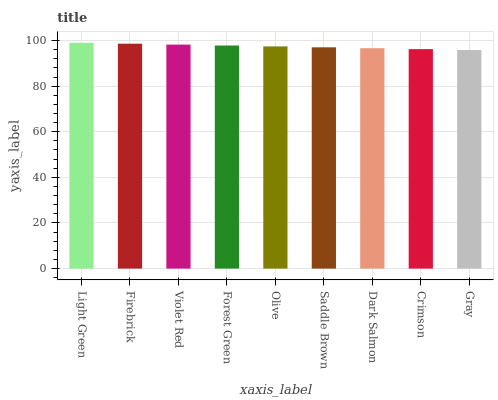Is Firebrick the minimum?
Answer yes or no. No. Is Firebrick the maximum?
Answer yes or no. No. Is Light Green greater than Firebrick?
Answer yes or no. Yes. Is Firebrick less than Light Green?
Answer yes or no. Yes. Is Firebrick greater than Light Green?
Answer yes or no. No. Is Light Green less than Firebrick?
Answer yes or no. No. Is Olive the high median?
Answer yes or no. Yes. Is Olive the low median?
Answer yes or no. Yes. Is Crimson the high median?
Answer yes or no. No. Is Crimson the low median?
Answer yes or no. No. 